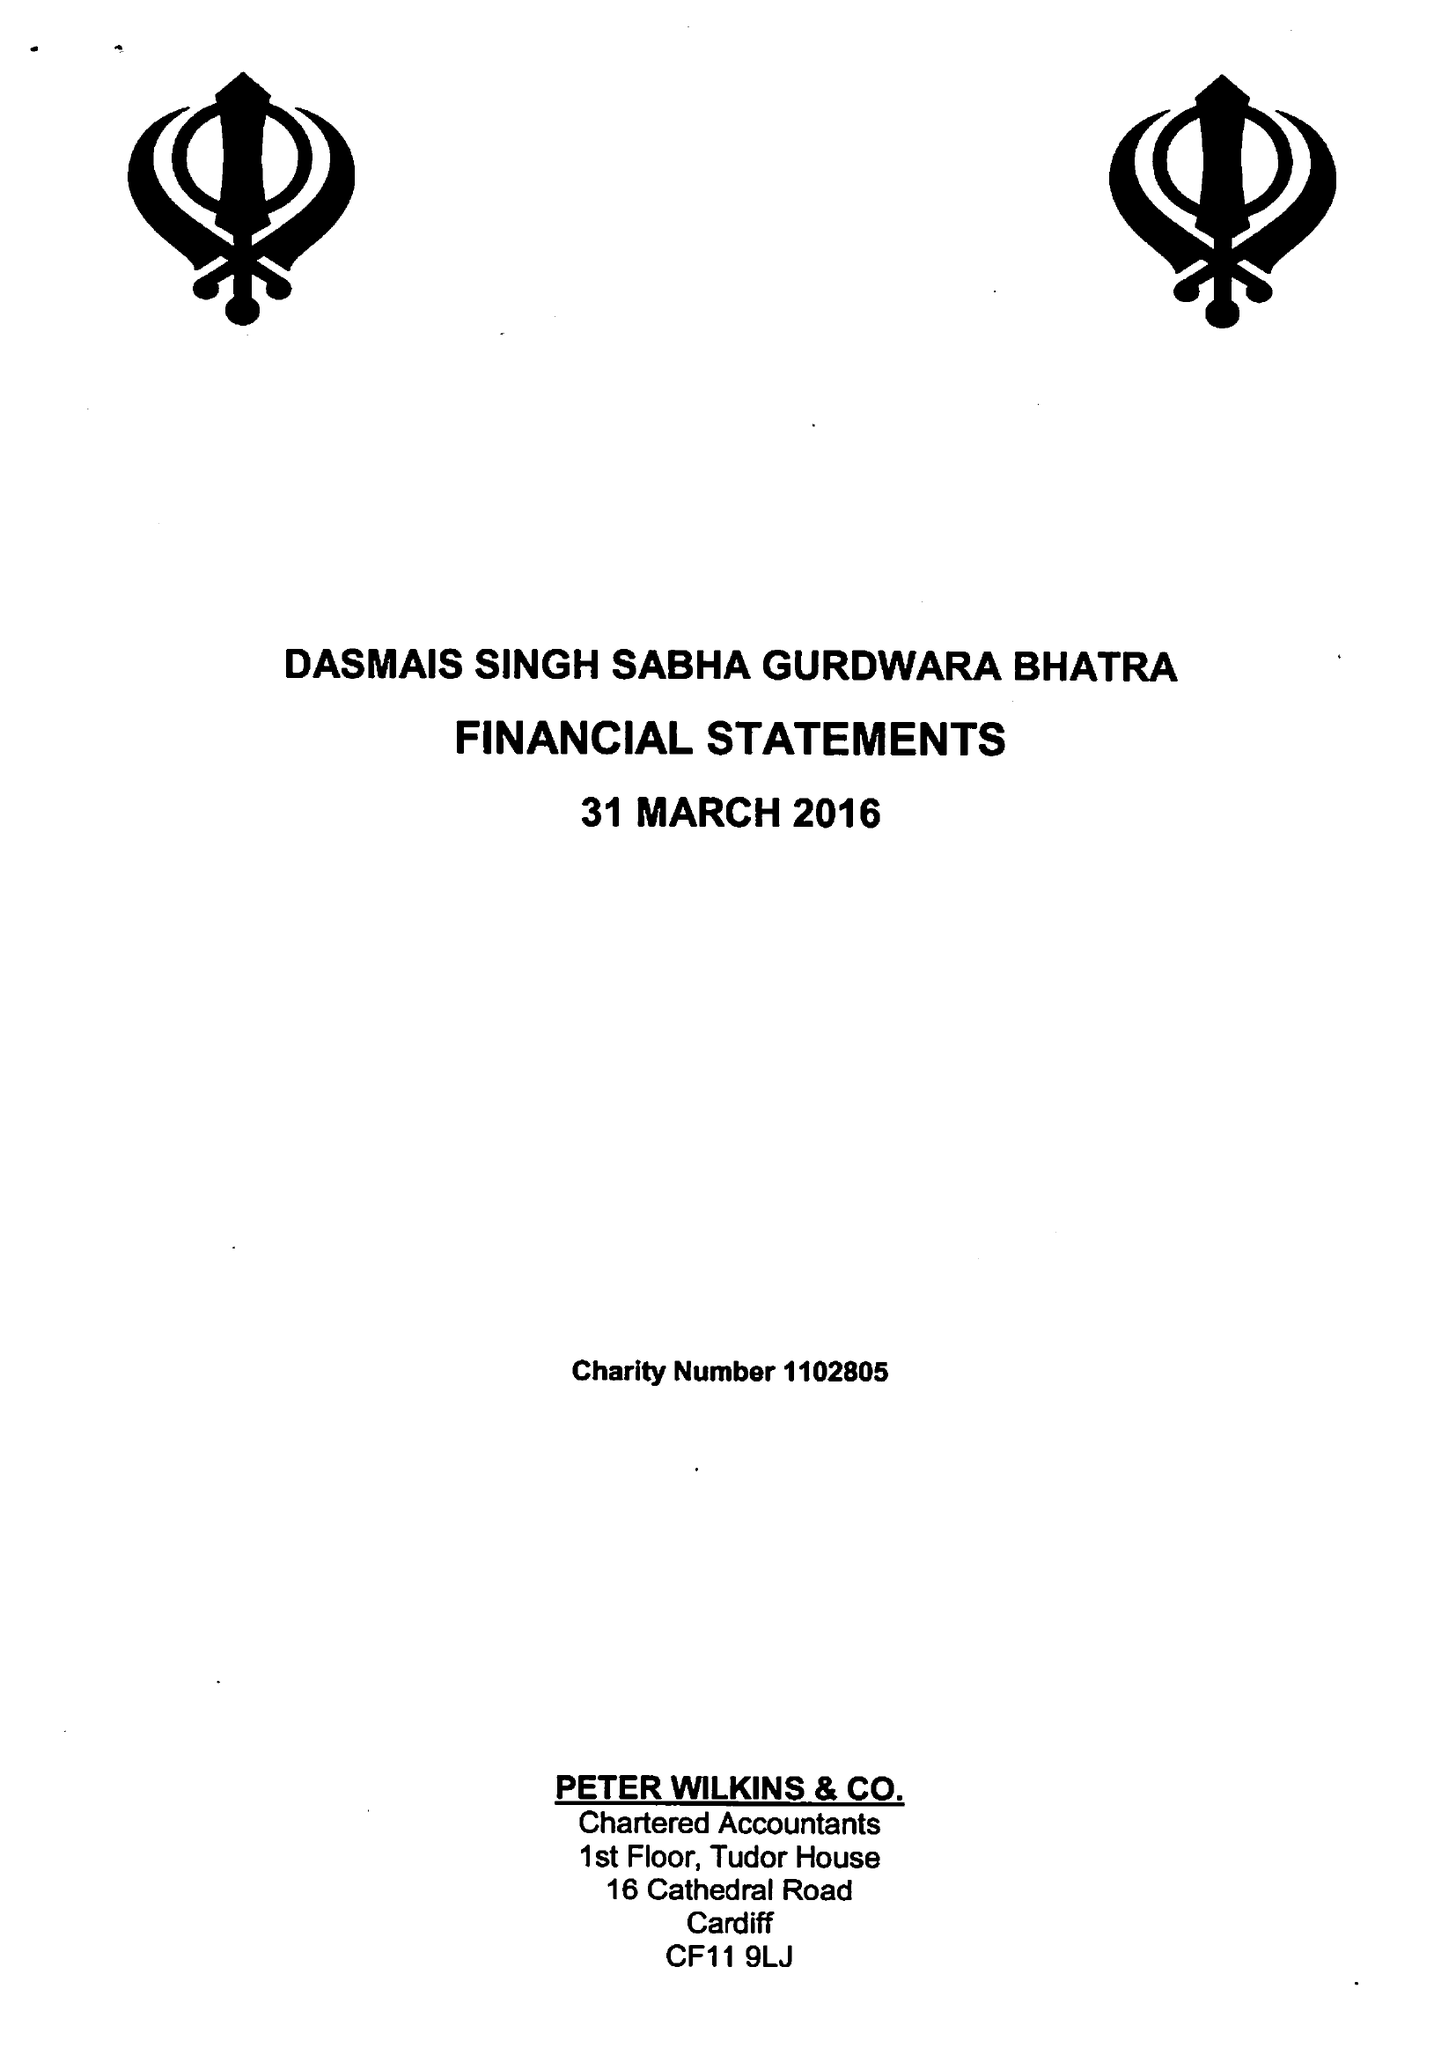What is the value for the address__street_line?
Answer the question using a single word or phrase. 97-99 TUDOR STREET 